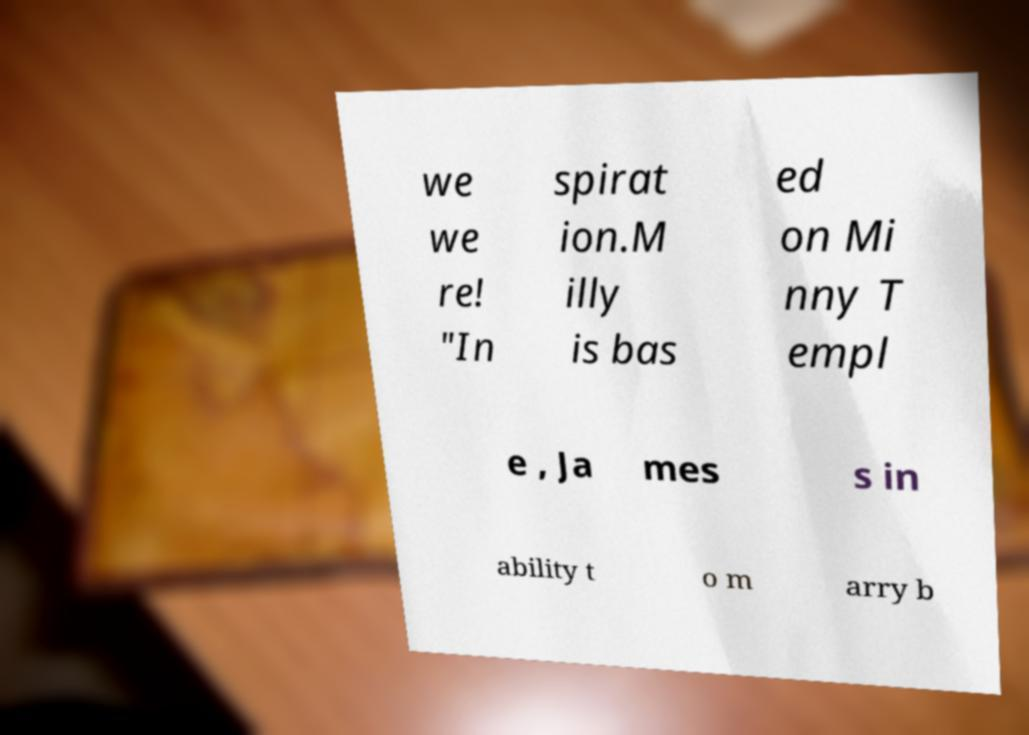Could you extract and type out the text from this image? we we re! "In spirat ion.M illy is bas ed on Mi nny T empl e , Ja mes s in ability t o m arry b 